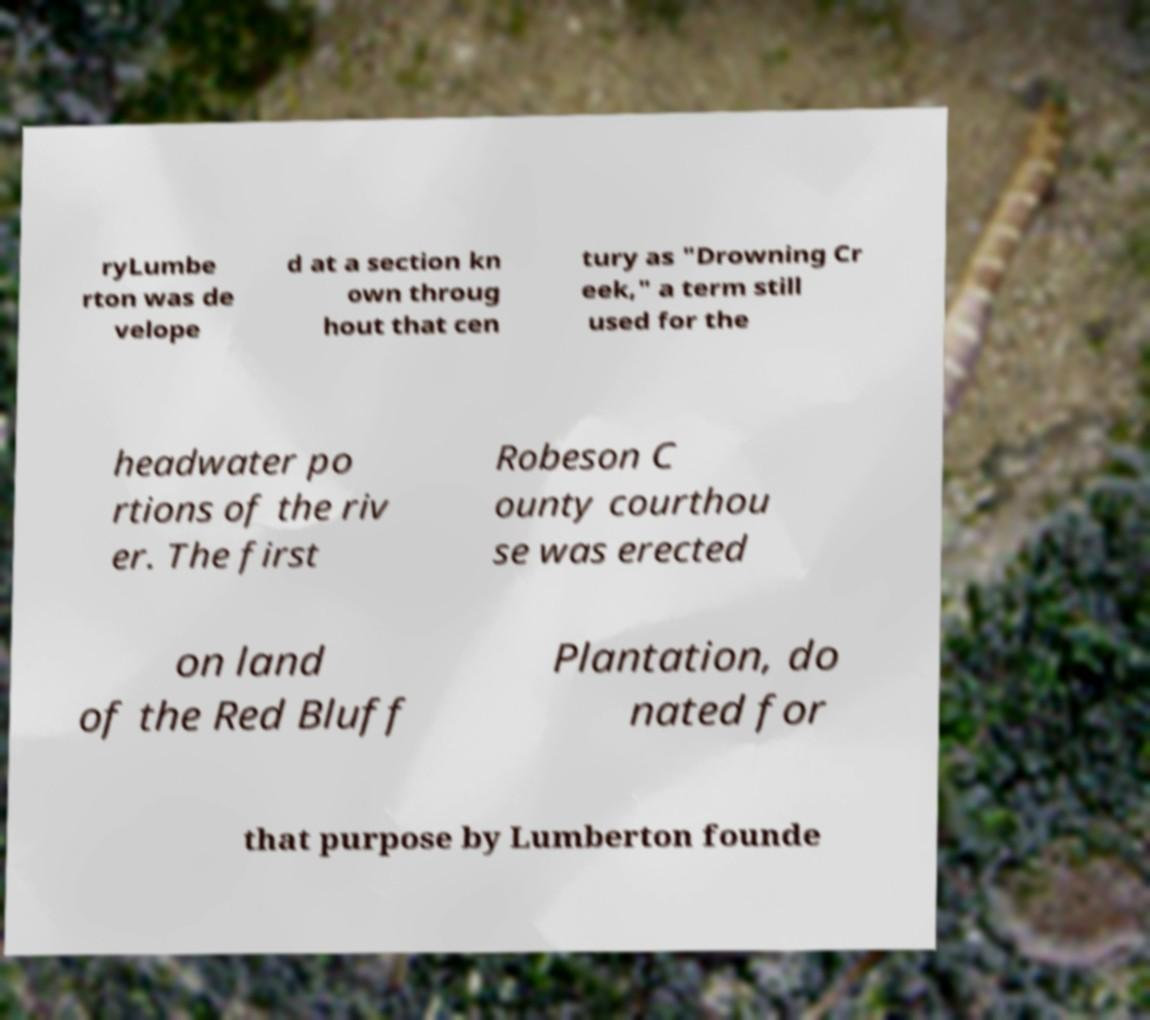Can you read and provide the text displayed in the image?This photo seems to have some interesting text. Can you extract and type it out for me? ryLumbe rton was de velope d at a section kn own throug hout that cen tury as "Drowning Cr eek," a term still used for the headwater po rtions of the riv er. The first Robeson C ounty courthou se was erected on land of the Red Bluff Plantation, do nated for that purpose by Lumberton founde 